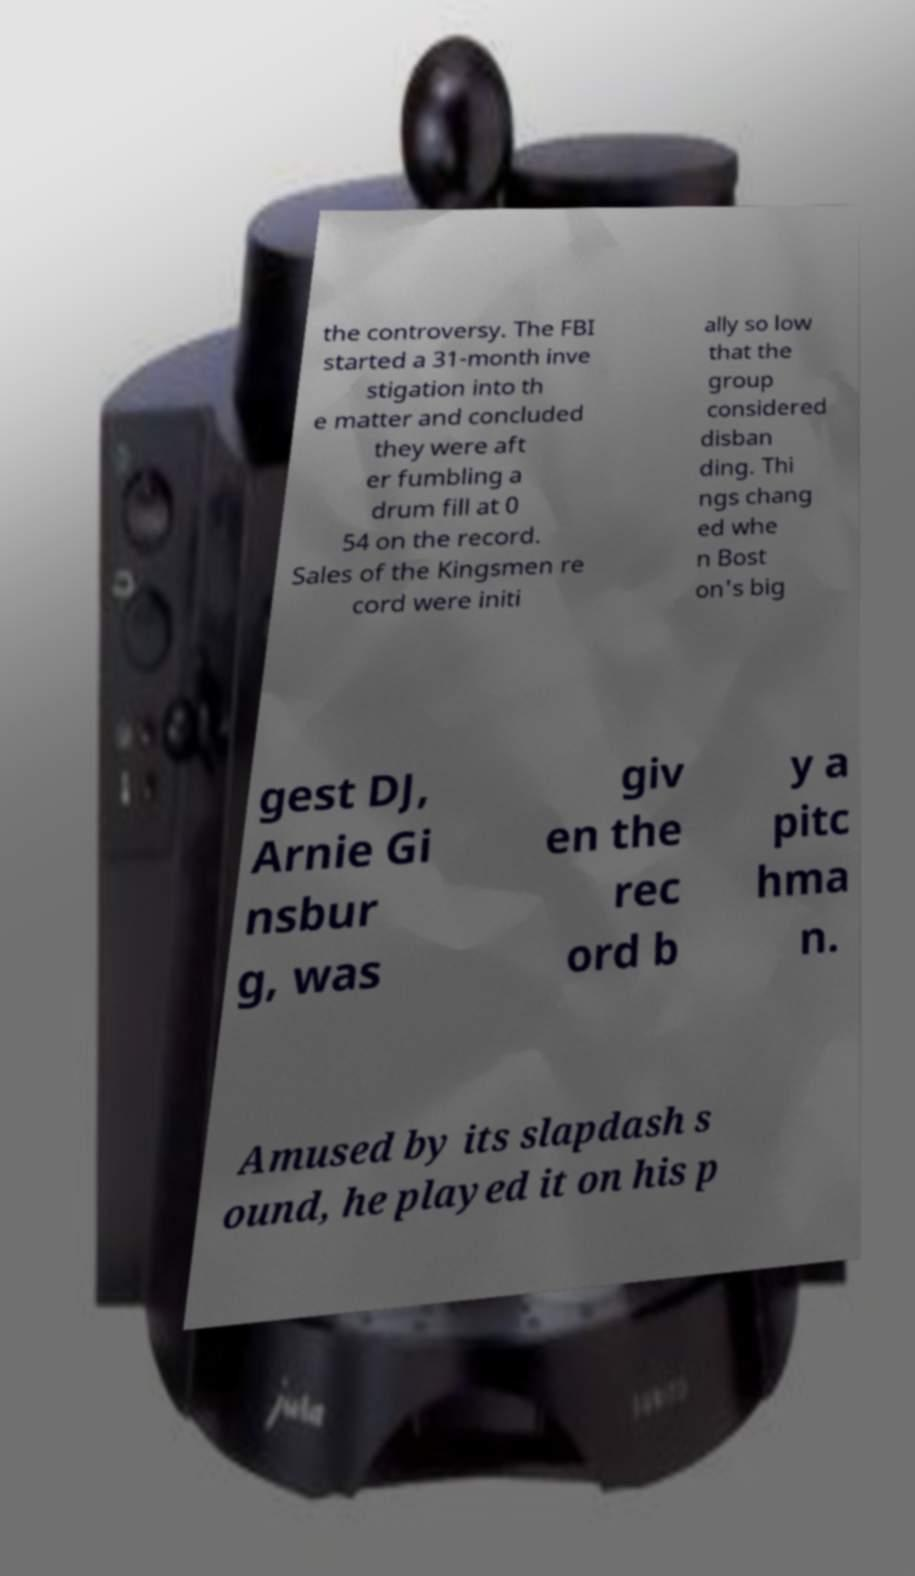Can you read and provide the text displayed in the image?This photo seems to have some interesting text. Can you extract and type it out for me? the controversy. The FBI started a 31-month inve stigation into th e matter and concluded they were aft er fumbling a drum fill at 0 54 on the record. Sales of the Kingsmen re cord were initi ally so low that the group considered disban ding. Thi ngs chang ed whe n Bost on's big gest DJ, Arnie Gi nsbur g, was giv en the rec ord b y a pitc hma n. Amused by its slapdash s ound, he played it on his p 